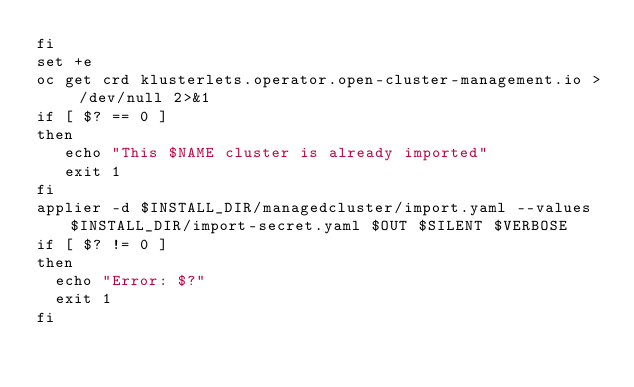Convert code to text. <code><loc_0><loc_0><loc_500><loc_500><_Bash_>fi
set +e
oc get crd klusterlets.operator.open-cluster-management.io > /dev/null 2>&1
if [ $? == 0 ]
then
   echo "This $NAME cluster is already imported"
   exit 1
fi
applier -d $INSTALL_DIR/managedcluster/import.yaml --values $INSTALL_DIR/import-secret.yaml $OUT $SILENT $VERBOSE
if [ $? != 0 ]
then
  echo "Error: $?"
  exit 1
fi</code> 